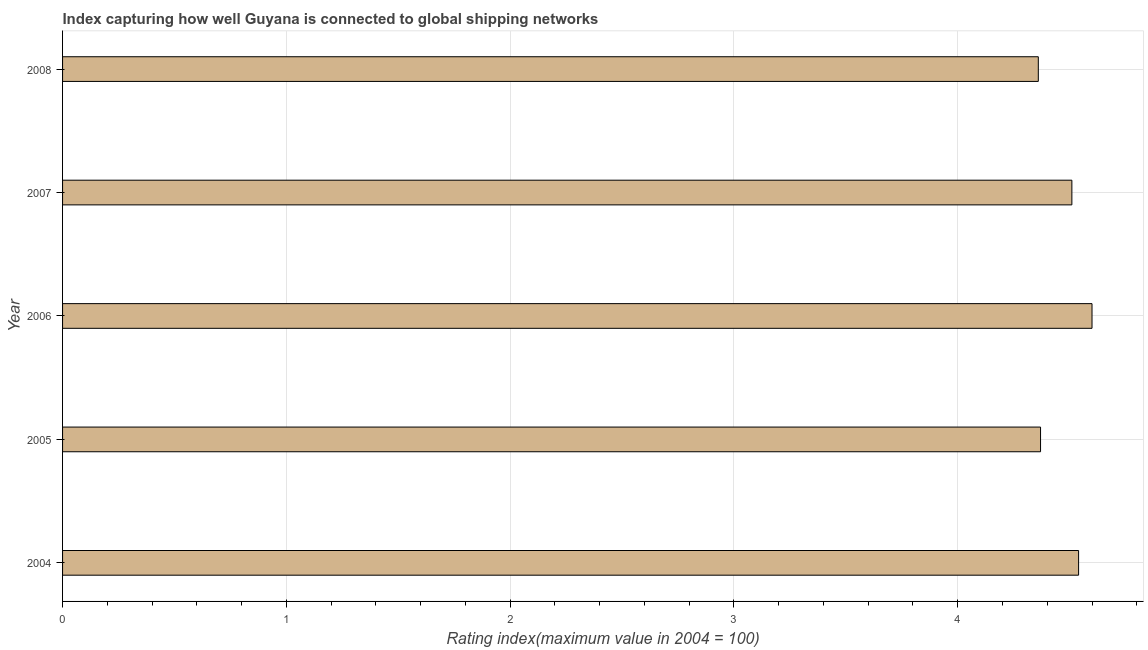Does the graph contain grids?
Your response must be concise. Yes. What is the title of the graph?
Ensure brevity in your answer.  Index capturing how well Guyana is connected to global shipping networks. What is the label or title of the X-axis?
Your answer should be very brief. Rating index(maximum value in 2004 = 100). Across all years, what is the minimum liner shipping connectivity index?
Ensure brevity in your answer.  4.36. In which year was the liner shipping connectivity index minimum?
Give a very brief answer. 2008. What is the sum of the liner shipping connectivity index?
Provide a short and direct response. 22.38. What is the average liner shipping connectivity index per year?
Make the answer very short. 4.48. What is the median liner shipping connectivity index?
Offer a terse response. 4.51. In how many years, is the liner shipping connectivity index greater than 2.4 ?
Make the answer very short. 5. Do a majority of the years between 2008 and 2004 (inclusive) have liner shipping connectivity index greater than 2 ?
Your answer should be compact. Yes. Is the liner shipping connectivity index in 2004 less than that in 2008?
Your response must be concise. No. What is the difference between the highest and the second highest liner shipping connectivity index?
Your answer should be compact. 0.06. Is the sum of the liner shipping connectivity index in 2004 and 2005 greater than the maximum liner shipping connectivity index across all years?
Keep it short and to the point. Yes. What is the difference between the highest and the lowest liner shipping connectivity index?
Keep it short and to the point. 0.24. Are all the bars in the graph horizontal?
Offer a very short reply. Yes. How many years are there in the graph?
Offer a terse response. 5. What is the Rating index(maximum value in 2004 = 100) of 2004?
Offer a terse response. 4.54. What is the Rating index(maximum value in 2004 = 100) in 2005?
Provide a succinct answer. 4.37. What is the Rating index(maximum value in 2004 = 100) of 2006?
Ensure brevity in your answer.  4.6. What is the Rating index(maximum value in 2004 = 100) of 2007?
Your answer should be compact. 4.51. What is the Rating index(maximum value in 2004 = 100) in 2008?
Your response must be concise. 4.36. What is the difference between the Rating index(maximum value in 2004 = 100) in 2004 and 2005?
Give a very brief answer. 0.17. What is the difference between the Rating index(maximum value in 2004 = 100) in 2004 and 2006?
Keep it short and to the point. -0.06. What is the difference between the Rating index(maximum value in 2004 = 100) in 2004 and 2007?
Offer a very short reply. 0.03. What is the difference between the Rating index(maximum value in 2004 = 100) in 2004 and 2008?
Your response must be concise. 0.18. What is the difference between the Rating index(maximum value in 2004 = 100) in 2005 and 2006?
Offer a terse response. -0.23. What is the difference between the Rating index(maximum value in 2004 = 100) in 2005 and 2007?
Provide a short and direct response. -0.14. What is the difference between the Rating index(maximum value in 2004 = 100) in 2006 and 2007?
Provide a succinct answer. 0.09. What is the difference between the Rating index(maximum value in 2004 = 100) in 2006 and 2008?
Offer a very short reply. 0.24. What is the ratio of the Rating index(maximum value in 2004 = 100) in 2004 to that in 2005?
Make the answer very short. 1.04. What is the ratio of the Rating index(maximum value in 2004 = 100) in 2004 to that in 2006?
Keep it short and to the point. 0.99. What is the ratio of the Rating index(maximum value in 2004 = 100) in 2004 to that in 2007?
Offer a very short reply. 1.01. What is the ratio of the Rating index(maximum value in 2004 = 100) in 2004 to that in 2008?
Offer a very short reply. 1.04. What is the ratio of the Rating index(maximum value in 2004 = 100) in 2005 to that in 2006?
Give a very brief answer. 0.95. What is the ratio of the Rating index(maximum value in 2004 = 100) in 2005 to that in 2008?
Offer a terse response. 1. What is the ratio of the Rating index(maximum value in 2004 = 100) in 2006 to that in 2007?
Keep it short and to the point. 1.02. What is the ratio of the Rating index(maximum value in 2004 = 100) in 2006 to that in 2008?
Offer a terse response. 1.05. What is the ratio of the Rating index(maximum value in 2004 = 100) in 2007 to that in 2008?
Ensure brevity in your answer.  1.03. 